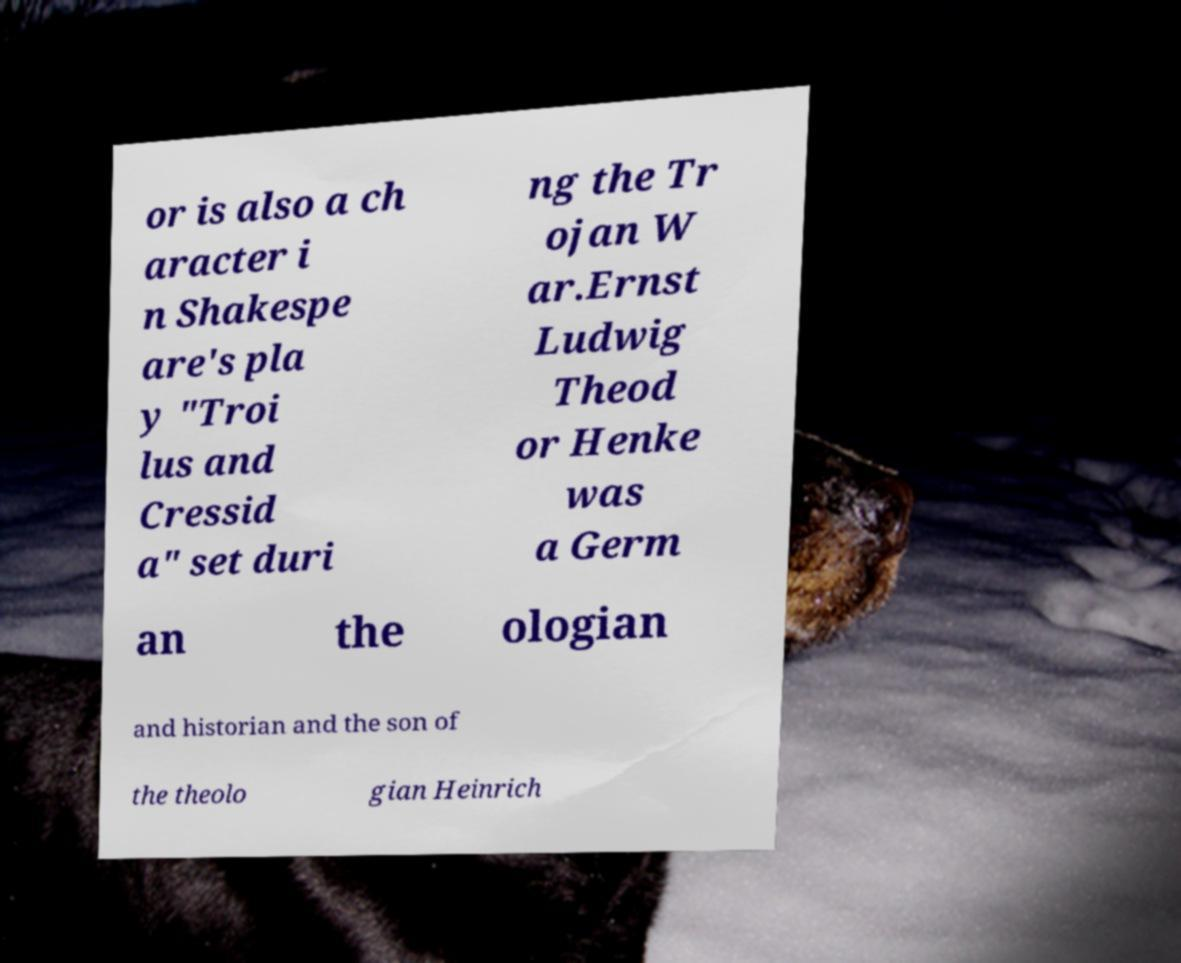Could you assist in decoding the text presented in this image and type it out clearly? or is also a ch aracter i n Shakespe are's pla y "Troi lus and Cressid a" set duri ng the Tr ojan W ar.Ernst Ludwig Theod or Henke was a Germ an the ologian and historian and the son of the theolo gian Heinrich 